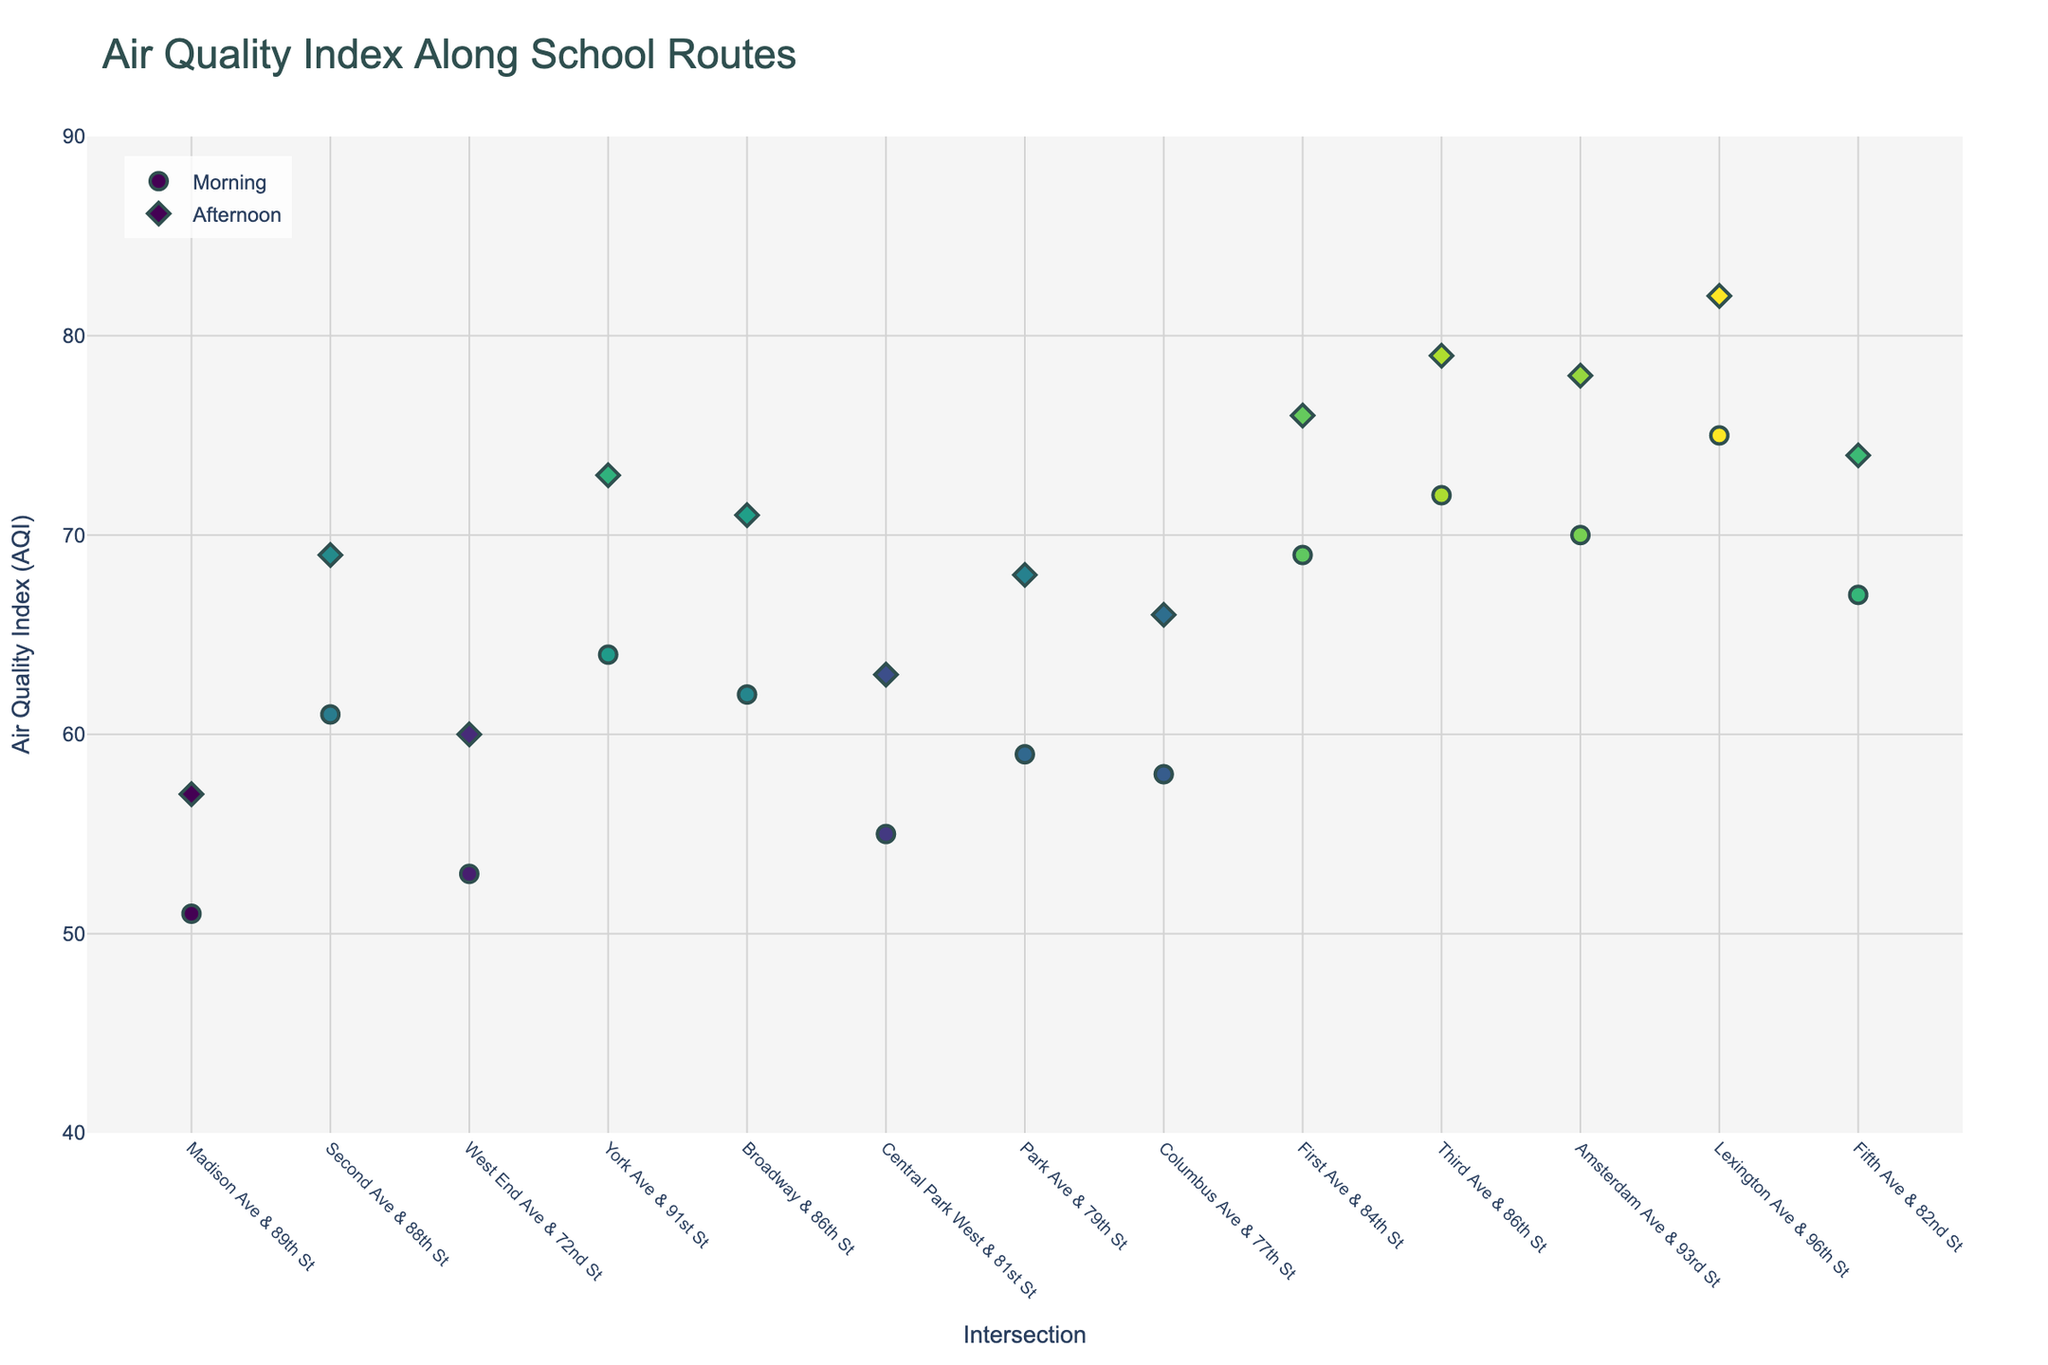What is the title of the plot? The title is usually displayed at the top center of the plot, providing a summary of what the figure represents.
Answer: Air Quality Index Along School Routes How many intersections are presented in the plot? By counting the unique x-axis labels, which represent different intersections, you can determine the number of intersections in the plot.
Answer: 13 Looking at the morning data points, which intersection has the highest AQI? Identify the data points marked for the morning, then locate the one with the highest y-axis value (AQI).
Answer: Lexington Ave & 96th St Which intersection has a lower AQI in the afternoon compared to the morning? Compare morning and afternoon AQI values for each intersection and find one where the afternoon value is lower.
Answer: Central Park West & 81st St What is the average AQI for the morning data points? Sum the AQI values for all morning data points and divide by the number of morning data points. (62 + 58 + 55 + 70 + 53 + 75 + 51 + 67 + 59 + 72 + 64 + 69 + 61) / 13
Answer: 63.69 Which intersection experienced the greatest increase in AQI from morning to afternoon? For each intersection, subtract the morning AQI from the afternoon AQI and identify the maximum difference.
Answer: Third Ave & 86th St (79 - 72 = 7) Comparing morning and afternoon data, is there a general trend in AQI values? Analyze the AQI values for both morning and afternoon, looking for overall rises or falls in values.
Answer: Generally higher in the afternoon Is there any intersection where the AQI values remain the same in the morning and afternoon? Compare the AQI values for each intersection in the morning and afternoon, looking for any intersection with identical values.
Answer: No List all the intersections where the AQI is above 70 in the afternoon. Identify afternoon data points with AQI values greater than 70 and note their corresponding intersections.
Answer: Amsterdam Ave & 93rd St, Lexington Ave & 96th St, Third Ave & 86th St, York Ave & 91st St, First Ave & 84th St What is the AQI range (difference between the maximum and minimum AQI) for the morning data? Subtract the minimum AQI value from the maximum AQI value among the morning data points. (75 - 51)
Answer: 24 